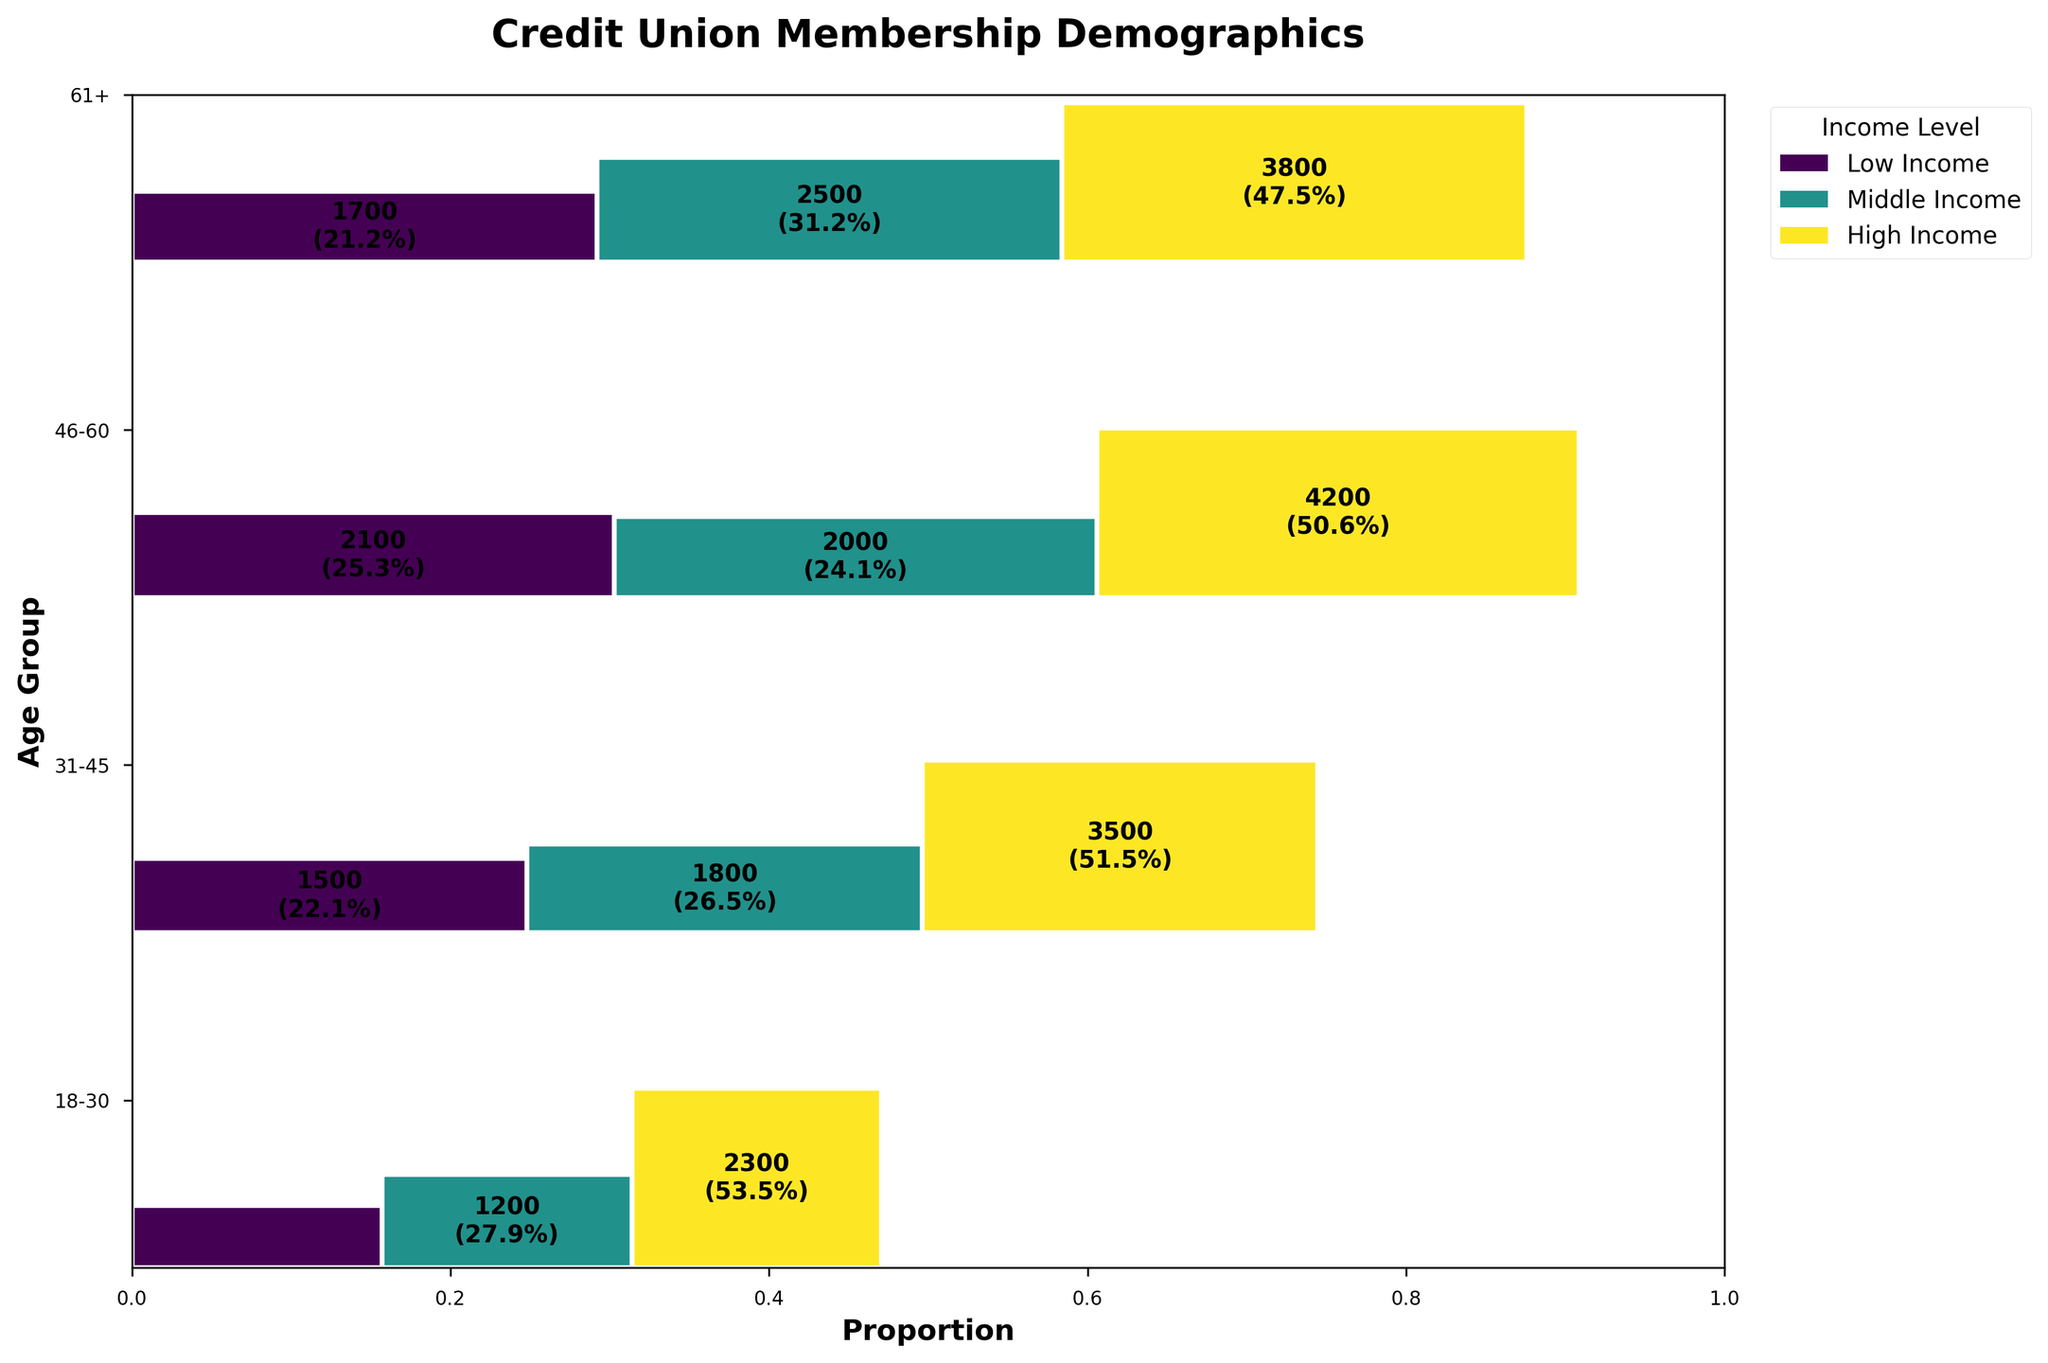What is the title of the figure? The title is usually located at the top of the figure. Reading the title provides an initial understanding of the content being presented.
Answer: Credit Union Membership Demographics Which age group has the highest overall membership count? By comparing the total width of each row, the row for the age group "46-60" appears widest, indicating the highest total membership count.
Answer: 46-60 How many low-income members are in the 61+ age group? Locate the 61+ age group row and identify the section that corresponds to low income. The number displayed within this section shows the membership count.
Answer: 2500 Which income level is most common in the 18-30 age group? In the 18-30 age group row, the section representing middle income is the tallest, indicating it is the most common income level for this group.
Answer: Middle Income Is the proportion of middle-income members in the 31-45 age group greater than that in the 46-60 age group? Calculate and compare the heights of the middle-income sections in the 31-45 and 46-60 age groups. The height in the 31-45 row is less than that in the 46-60 row.
Answer: No Which age group has the smallest proportion of high-income members? Compare the heights of the high-income sections across all age groups. The smallest proportion is in the 18-30 age group.
Answer: 18-30 What is the total membership count for middle-income members across all age groups? Sum the middle-income counts across all age groups: 2300 (18-30) + 3500 (31-45) + 4200 (46-60) + 3800 (61+).
Answer: 13800 Is there an age group where the proportion of low-income members is greater than the proportion of middle-income members? In the 61+ age group, the height of the low-income section is greater than the height of the middle-income section.
Answer: Yes Which income level has the highest membership count in the 46-60 age group? For the 46-60 age group row, identify which section (low, middle, high) has the highest membership count by comparing their heights. The middle-income section is the tallest.
Answer: Middle Income Compare the proportion of high-income members between the 31-45 and 46-60 age groups. Which group has a higher proportion? Comparing the heights of the high-income sections for both age groups, the 46-60 age group has a higher proportion of high-income members than the 31-45 age group.
Answer: 46-60 